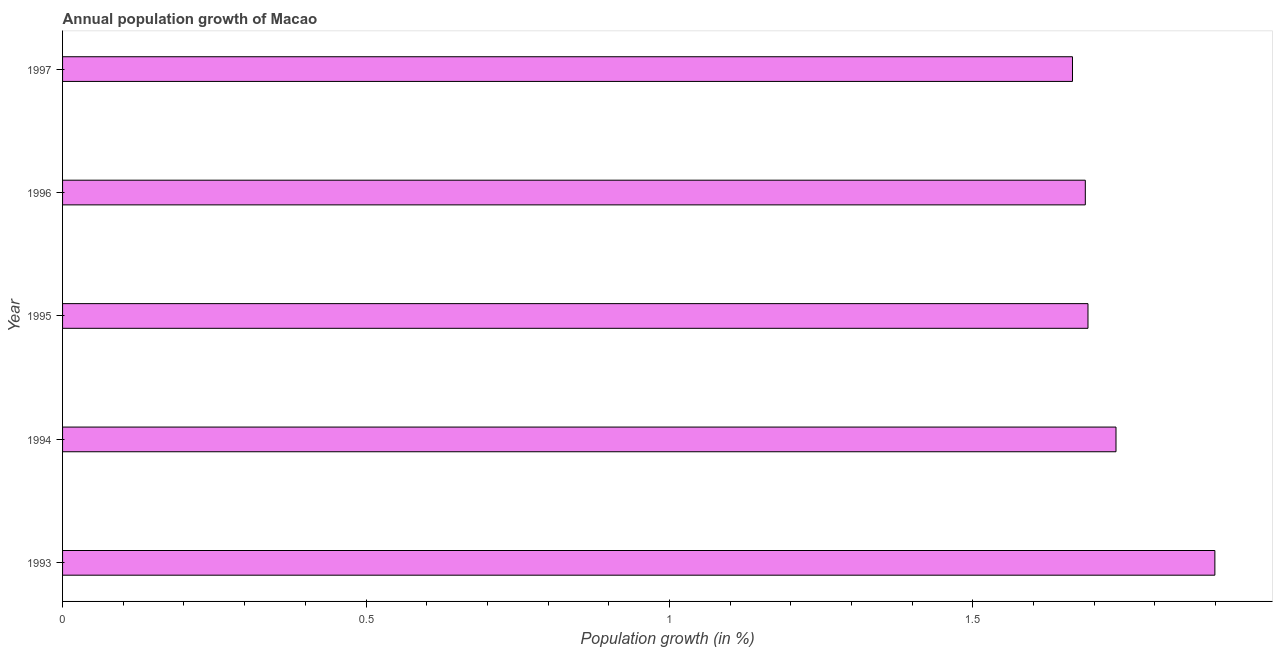Does the graph contain any zero values?
Make the answer very short. No. What is the title of the graph?
Provide a succinct answer. Annual population growth of Macao. What is the label or title of the X-axis?
Keep it short and to the point. Population growth (in %). What is the label or title of the Y-axis?
Your response must be concise. Year. What is the population growth in 1995?
Offer a terse response. 1.69. Across all years, what is the maximum population growth?
Offer a very short reply. 1.9. Across all years, what is the minimum population growth?
Offer a terse response. 1.66. In which year was the population growth maximum?
Your answer should be compact. 1993. In which year was the population growth minimum?
Your answer should be compact. 1997. What is the sum of the population growth?
Offer a very short reply. 8.67. What is the difference between the population growth in 1993 and 1994?
Offer a very short reply. 0.16. What is the average population growth per year?
Your answer should be very brief. 1.74. What is the median population growth?
Make the answer very short. 1.69. Do a majority of the years between 1997 and 1996 (inclusive) have population growth greater than 0.3 %?
Provide a succinct answer. No. What is the ratio of the population growth in 1995 to that in 1997?
Your answer should be compact. 1.01. What is the difference between the highest and the second highest population growth?
Provide a short and direct response. 0.16. What is the difference between the highest and the lowest population growth?
Give a very brief answer. 0.23. How many bars are there?
Your answer should be compact. 5. What is the Population growth (in %) of 1993?
Give a very brief answer. 1.9. What is the Population growth (in %) of 1994?
Your answer should be very brief. 1.74. What is the Population growth (in %) of 1995?
Provide a succinct answer. 1.69. What is the Population growth (in %) in 1996?
Keep it short and to the point. 1.69. What is the Population growth (in %) in 1997?
Your answer should be very brief. 1.66. What is the difference between the Population growth (in %) in 1993 and 1994?
Provide a short and direct response. 0.16. What is the difference between the Population growth (in %) in 1993 and 1995?
Provide a succinct answer. 0.21. What is the difference between the Population growth (in %) in 1993 and 1996?
Your answer should be compact. 0.21. What is the difference between the Population growth (in %) in 1993 and 1997?
Your answer should be compact. 0.23. What is the difference between the Population growth (in %) in 1994 and 1995?
Your answer should be compact. 0.05. What is the difference between the Population growth (in %) in 1994 and 1996?
Provide a succinct answer. 0.05. What is the difference between the Population growth (in %) in 1994 and 1997?
Make the answer very short. 0.07. What is the difference between the Population growth (in %) in 1995 and 1996?
Make the answer very short. 0. What is the difference between the Population growth (in %) in 1995 and 1997?
Your response must be concise. 0.03. What is the difference between the Population growth (in %) in 1996 and 1997?
Your answer should be very brief. 0.02. What is the ratio of the Population growth (in %) in 1993 to that in 1994?
Ensure brevity in your answer.  1.09. What is the ratio of the Population growth (in %) in 1993 to that in 1995?
Keep it short and to the point. 1.12. What is the ratio of the Population growth (in %) in 1993 to that in 1996?
Your answer should be very brief. 1.13. What is the ratio of the Population growth (in %) in 1993 to that in 1997?
Your answer should be compact. 1.14. What is the ratio of the Population growth (in %) in 1994 to that in 1997?
Give a very brief answer. 1.04. What is the ratio of the Population growth (in %) in 1995 to that in 1997?
Give a very brief answer. 1.01. What is the ratio of the Population growth (in %) in 1996 to that in 1997?
Provide a short and direct response. 1.01. 